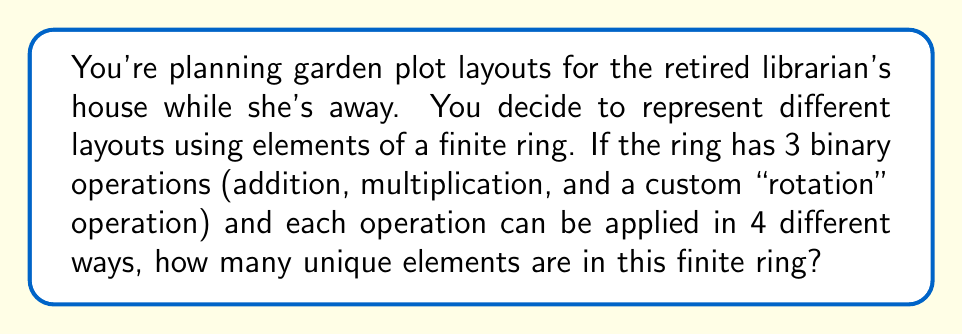Can you answer this question? To solve this problem, we need to understand the structure of finite rings and how the number of operations relates to the number of elements.

1) In a finite ring, each element must be uniquely defined by how it behaves under the ring's operations.

2) We have 3 operations: addition, multiplication, and a custom "rotation" operation.

3) Each operation can be applied in 4 different ways. This means that for each operation, an element can behave in one of 4 possible ways.

4) To determine the total number of possible unique elements, we need to consider all possible combinations of behaviors under these operations.

5) The number of possible combinations is the product of the number of possibilities for each operation:

   $$ 4 \times 4 \times 4 = 4^3 = 64 $$

6) This means that there are 64 unique ways an element can behave under the three operations.

7) In a ring, each element must have a unique behavior. Therefore, the number of unique behaviors determines the number of elements in the ring.

Thus, the finite ring representing garden plot layouts has 64 elements.
Answer: 64 elements 